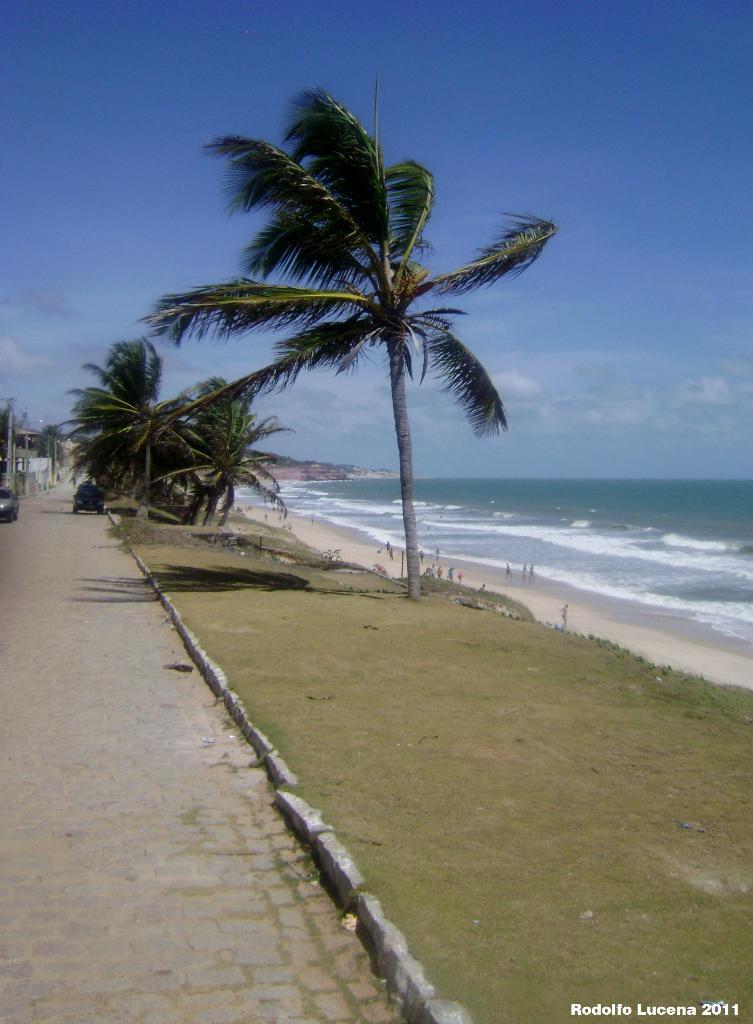How would you summarize this image in a sentence or two? In this image I can see the road, two vehicles on the road, some grass, few trees, the water and few persons on the beach. In the background I can see the sky. 